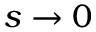Convert formula to latex. <formula><loc_0><loc_0><loc_500><loc_500>s \to 0</formula> 